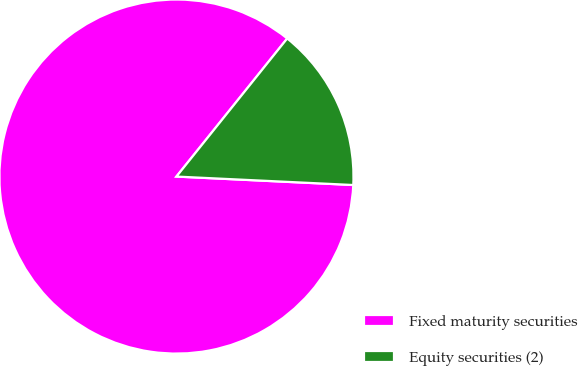<chart> <loc_0><loc_0><loc_500><loc_500><pie_chart><fcel>Fixed maturity securities<fcel>Equity securities (2)<nl><fcel>85.0%<fcel>15.0%<nl></chart> 